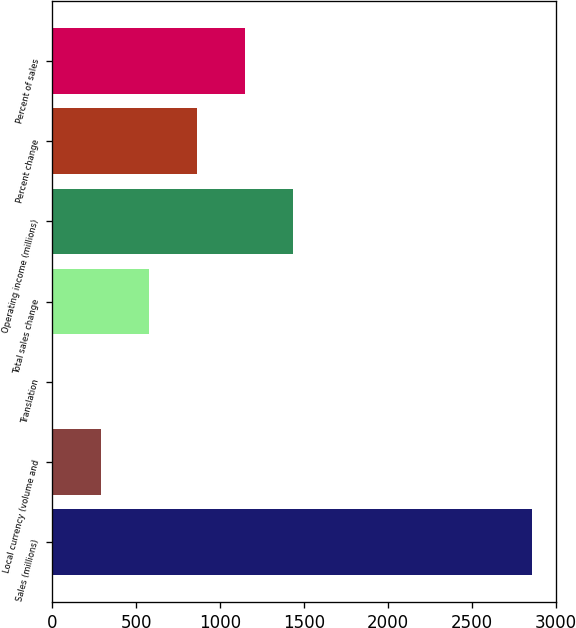<chart> <loc_0><loc_0><loc_500><loc_500><bar_chart><fcel>Sales (millions)<fcel>Local currency (volume and<fcel>Translation<fcel>Total sales change<fcel>Operating income (millions)<fcel>Percent change<fcel>Percent of sales<nl><fcel>2861<fcel>288.62<fcel>2.8<fcel>574.44<fcel>1431.9<fcel>860.26<fcel>1146.08<nl></chart> 